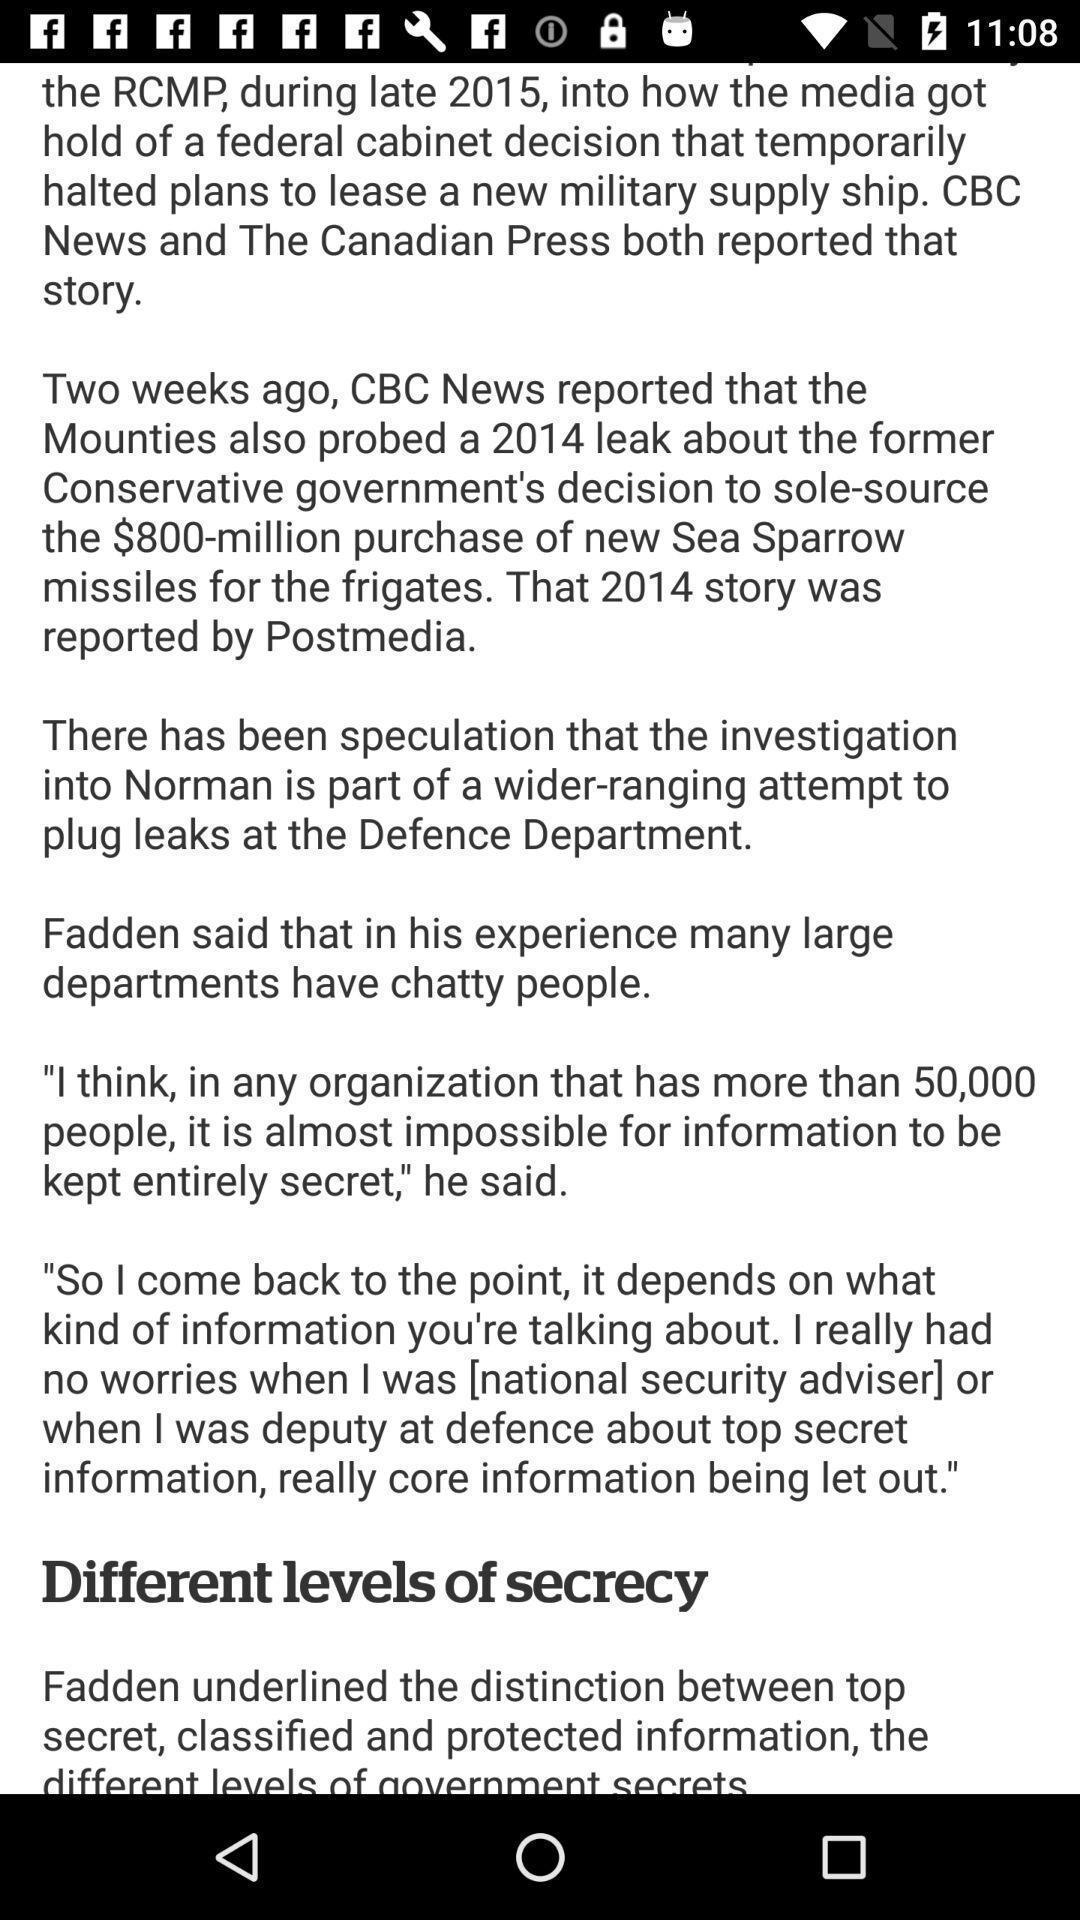Describe the visual elements of this screenshot. Screen showing page of an news application. 